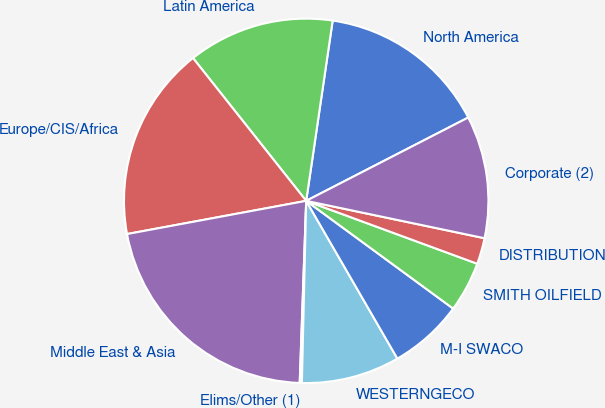Convert chart. <chart><loc_0><loc_0><loc_500><loc_500><pie_chart><fcel>North America<fcel>Latin America<fcel>Europe/CIS/Africa<fcel>Middle East & Asia<fcel>Elims/Other (1)<fcel>WESTERNGECO<fcel>M-I SWACO<fcel>SMITH OILFIELD<fcel>DISTRIBUTION<fcel>Corporate (2)<nl><fcel>15.12%<fcel>12.99%<fcel>17.25%<fcel>21.52%<fcel>0.19%<fcel>8.72%<fcel>6.59%<fcel>4.46%<fcel>2.32%<fcel>10.85%<nl></chart> 